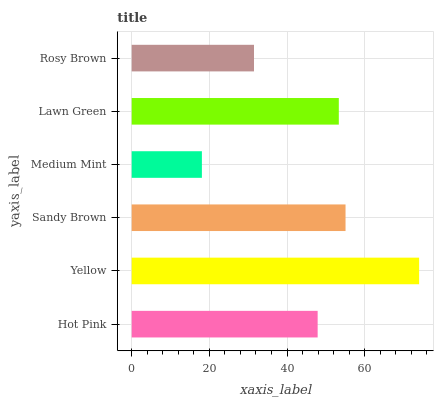Is Medium Mint the minimum?
Answer yes or no. Yes. Is Yellow the maximum?
Answer yes or no. Yes. Is Sandy Brown the minimum?
Answer yes or no. No. Is Sandy Brown the maximum?
Answer yes or no. No. Is Yellow greater than Sandy Brown?
Answer yes or no. Yes. Is Sandy Brown less than Yellow?
Answer yes or no. Yes. Is Sandy Brown greater than Yellow?
Answer yes or no. No. Is Yellow less than Sandy Brown?
Answer yes or no. No. Is Lawn Green the high median?
Answer yes or no. Yes. Is Hot Pink the low median?
Answer yes or no. Yes. Is Sandy Brown the high median?
Answer yes or no. No. Is Lawn Green the low median?
Answer yes or no. No. 